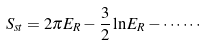<formula> <loc_0><loc_0><loc_500><loc_500>S _ { s t } = 2 \pi E _ { R } - \frac { 3 } { 2 } \ln E _ { R } - \cdots \cdots</formula> 